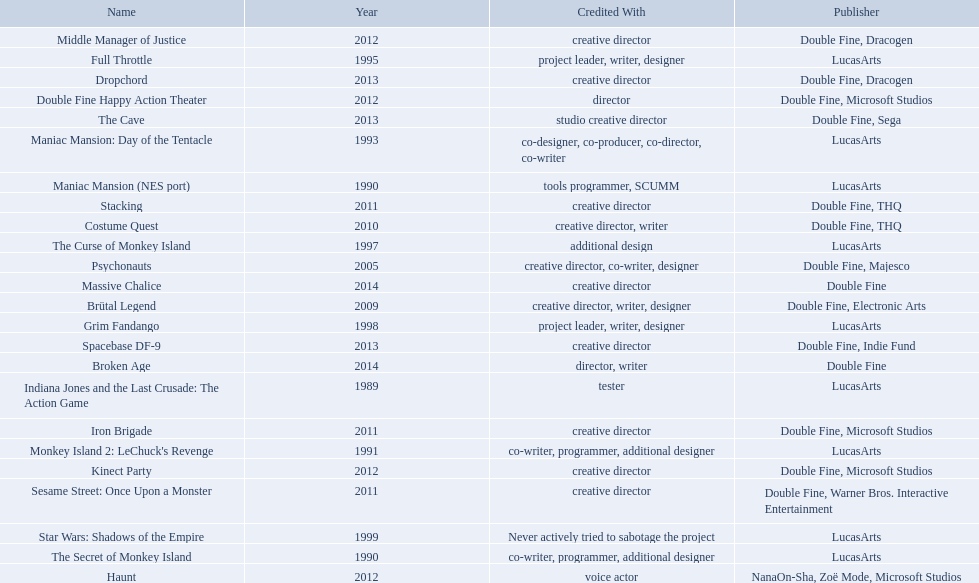Which game is credited with a creative director? Creative director, co-writer, designer, creative director, writer, designer, creative director, writer, creative director, creative director, creative director, creative director, creative director, creative director, creative director, creative director. Of these games, which also has warner bros. interactive listed as creative director? Sesame Street: Once Upon a Monster. 